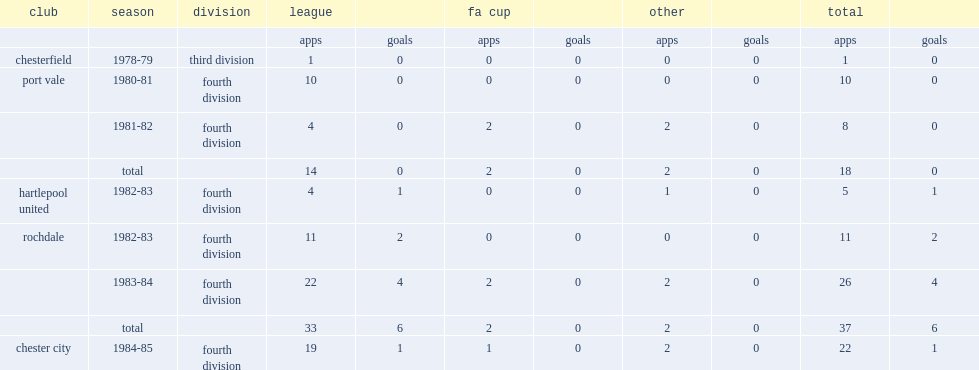Which division did higgins play for chesterfield in the 1978-79 season? Third division. 